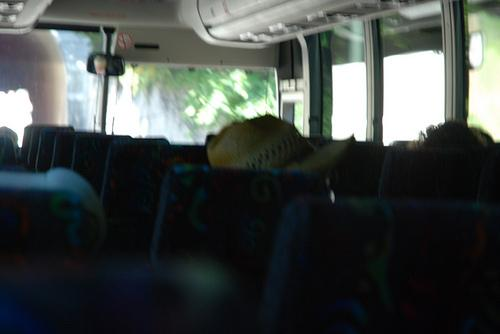Mention one rule visible in the image. There is a no smoking sign prominently displayed on the inside windshield of the bus. Mention one object and its location in the image. A no smoking sticker is located at the front of the bus. Provide a brief description of the scene captured in the image. Passengers inside a bus with multicolored seats, a person wearing a straw hat, and green trees visible through the windows. Describe the seating arrangement inside the bus. The bus has rows of blue seats, along with storage compartments above the seats for the passengers' belongings. Comment on the attire of a passenger in the image. One passenger is wearing a straw hat while sitting on the bus. Write a sentence about the bus driver in the image. The bus driver can be seen through the reflection in the rearview mirror. Explain the function of a specific object in the image. The rear view mirror mounted on the front windshield allows the bus driver to see the traffic behind the bus. Describe the outside environment visible from the bus. Green trees and bright sunlight can be seen through the bus windows. Identify an unusual feature in the image. A reflection of the bus driver can be seen in the rear view mirror. Describe the appearance of the bus and its surroundings. The bus has many side windows, rows of blue seats, and a front door; outside, green trees and bright sunlight are visible. Find the driver's cabin with a steering wheel at the back of the bus. This instruction is misleading because the given information does not mention any driver's cabin or steering wheel, and it is generally assumed that the driver's area is at the front of the bus. Isn't it dark and cloudy outside the bus? This instruction contradicts the given information that mentions it is sunny and bright outside the bus. Do the tree branches outside the front bus window have orange leaves? This instruction is misleading as the given information mentions tree branches with green leaves outside the front bus window. Find the pink seats in the bus and count the number of rows. The instruction is misleading as there is no information about pink seats. The given information states that there are multi-colored seats and blue seats. Can you see passengers standing and holding the handrails inside the bus? The instruction is misleading because the given information refers to passengers sitting on their seats, not standing. Can you find the sunroof on the bus? The given information does not mention a sunroof on the bus, making it misleading to look for it. Look for a purple hat on the head of one of the passengers. The instruction is misleading as the given information only describes a person wearing a straw hat, with no mention of color. Observe a bicycle placed next to the storage compartment above the seats. The instruction is misleading as there is no information about a bicycle near the storage compartment. Does the bus have a yellow no smoking sticker at the back of the bus? The instruction is misleading because the no smoking sticker is at the front of the bus, and there is no mention of its color in the given information. Try to locate a dog sitting on one of the bus seats. There's no information about a dog sitting inside the bus. Thus, it's misleading to look for a dog. 